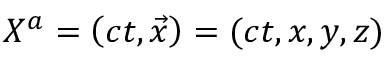Convert formula to latex. <formula><loc_0><loc_0><loc_500><loc_500>X ^ { a } = \left ( c t , { \vec { x } } \right ) = ( c t , x , y , z )</formula> 